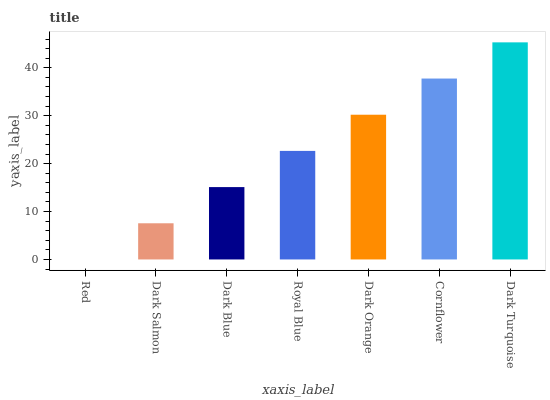Is Red the minimum?
Answer yes or no. Yes. Is Dark Turquoise the maximum?
Answer yes or no. Yes. Is Dark Salmon the minimum?
Answer yes or no. No. Is Dark Salmon the maximum?
Answer yes or no. No. Is Dark Salmon greater than Red?
Answer yes or no. Yes. Is Red less than Dark Salmon?
Answer yes or no. Yes. Is Red greater than Dark Salmon?
Answer yes or no. No. Is Dark Salmon less than Red?
Answer yes or no. No. Is Royal Blue the high median?
Answer yes or no. Yes. Is Royal Blue the low median?
Answer yes or no. Yes. Is Dark Turquoise the high median?
Answer yes or no. No. Is Dark Blue the low median?
Answer yes or no. No. 